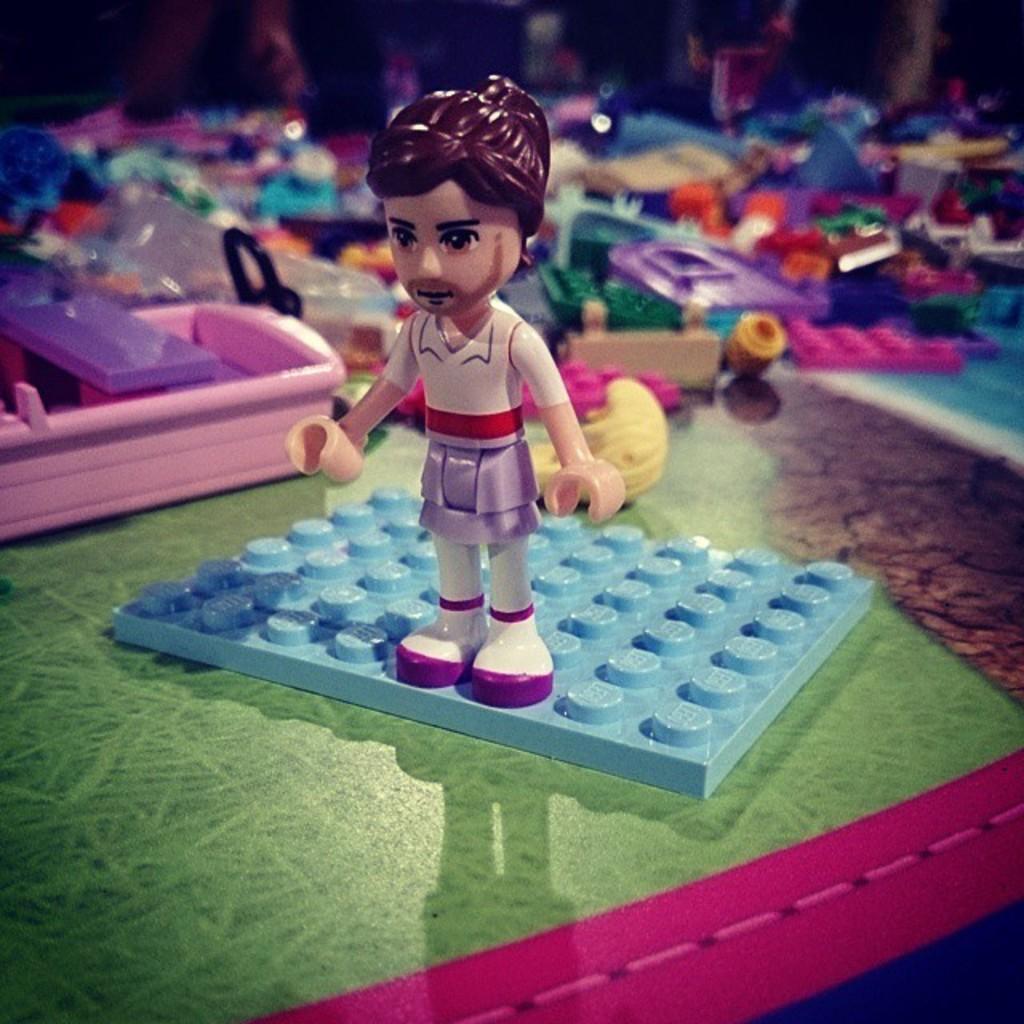In one or two sentences, can you explain what this image depicts? In this image we can see toys on the mat and a blurry background. 